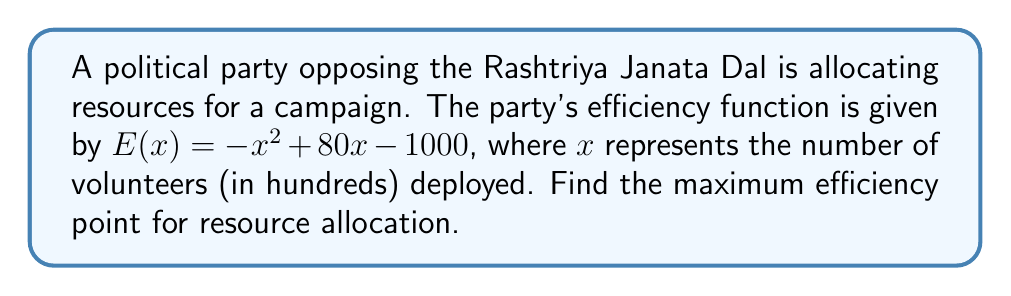Provide a solution to this math problem. To find the maximum efficiency point, we need to follow these steps:

1) The efficiency function $E(x)$ is a quadratic function. Its maximum point occurs at the vertex of the parabola.

2) For a quadratic function in the form $f(x) = ax^2 + bx + c$, the x-coordinate of the vertex is given by $x = -\frac{b}{2a}$.

3) In our case, $a = -1$, $b = 80$, and $c = -1000$.

4) Substituting these values:

   $x = -\frac{80}{2(-1)} = -\frac{80}{-2} = 40$

5) This means the maximum efficiency occurs when 40 hundred (or 4000) volunteers are deployed.

6) To find the maximum efficiency value, we substitute $x = 40$ into the original function:

   $E(40) = -(40)^2 + 80(40) - 1000$
   $= -1600 + 3200 - 1000$
   $= 600$

Therefore, the maximum efficiency is 600 units when 4000 volunteers are deployed.
Answer: (40, 600) 